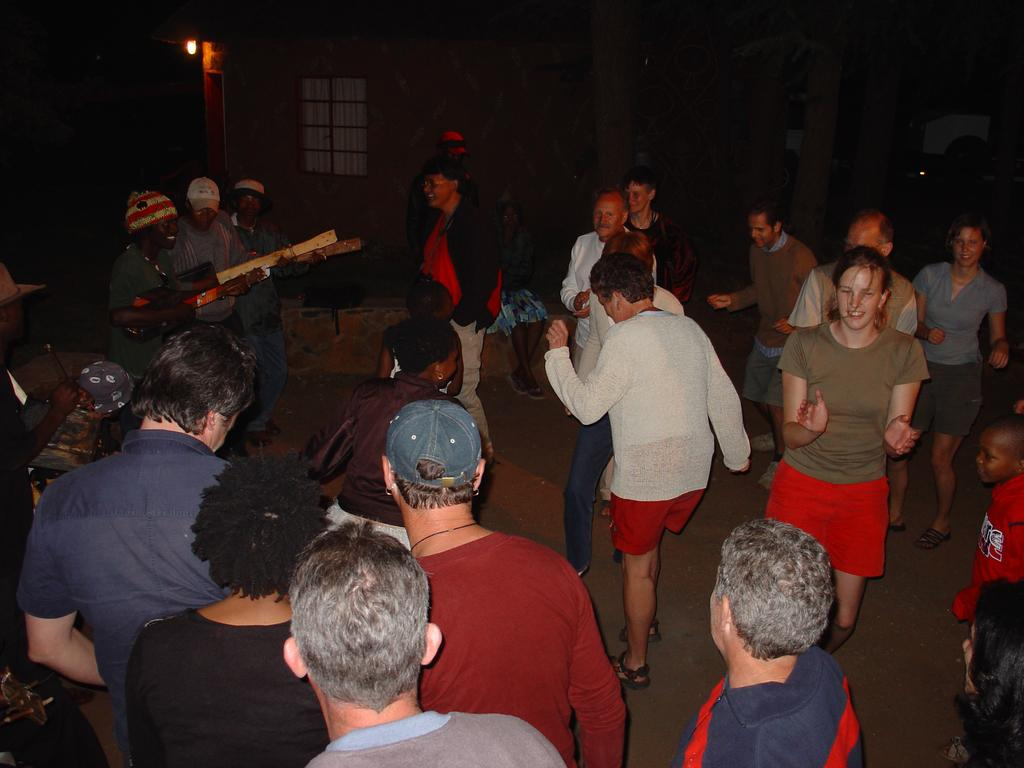What can be seen in the image? There are people standing in the image. Where are the people standing? The people are standing on the floor. What can be seen in the background of the image? There is a window visible in the background of the image. What type of cheese is being served in the image? There is no cheese present in the image. What time of day is it in the image? The time of day is not mentioned or depicted in the image. 